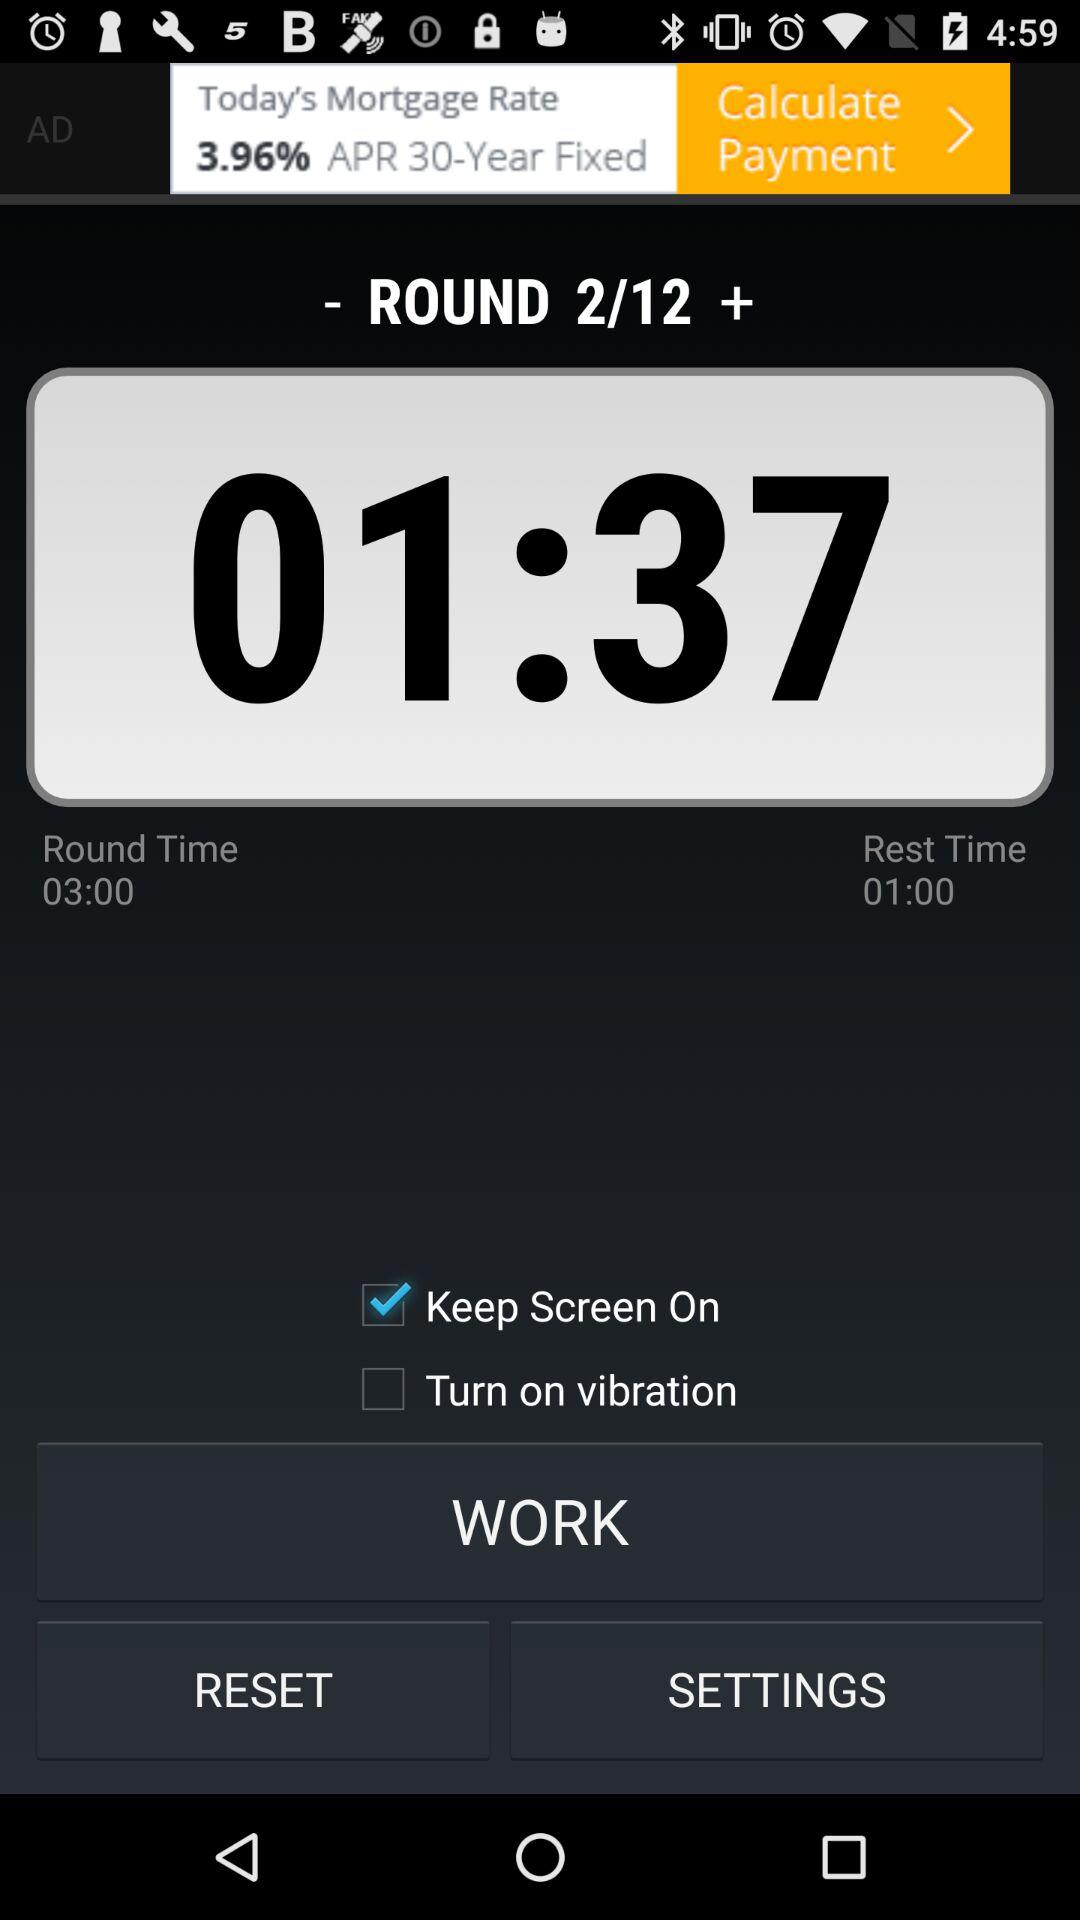What is the current state of "Turn on vibration"? The current state is "off". 